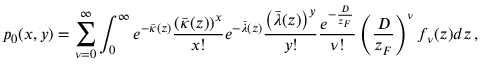Convert formula to latex. <formula><loc_0><loc_0><loc_500><loc_500>p _ { 0 } ( x , y ) = \sum _ { \nu = 0 } ^ { \infty } \int _ { 0 } ^ { \infty } e ^ { - \bar { \kappa } ( z ) } \frac { \left ( \bar { \kappa } ( z ) \right ) ^ { x } } { x ! } e ^ { - \bar { \lambda } ( z ) } \frac { \left ( \bar { \lambda } ( z ) \right ) ^ { y } } { y ! } \frac { e ^ { - \frac { D } { z _ { F } } } } { \nu ! } \left ( \frac { D } { z _ { F } } \right ) ^ { \nu } f _ { \nu } ( z ) d z \, ,</formula> 